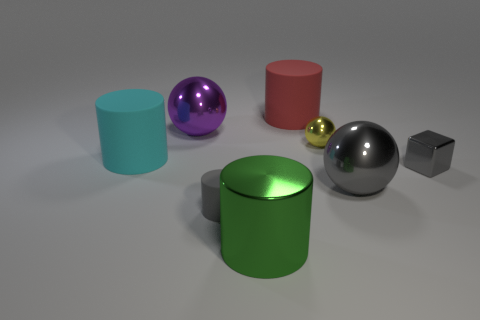What shapes are present in the image? The image showcases a mix of geometric shapes: there are three cylinders (one cyan, one green, and one red), two spheres (one purple and one yellow), and one cube (grey). 